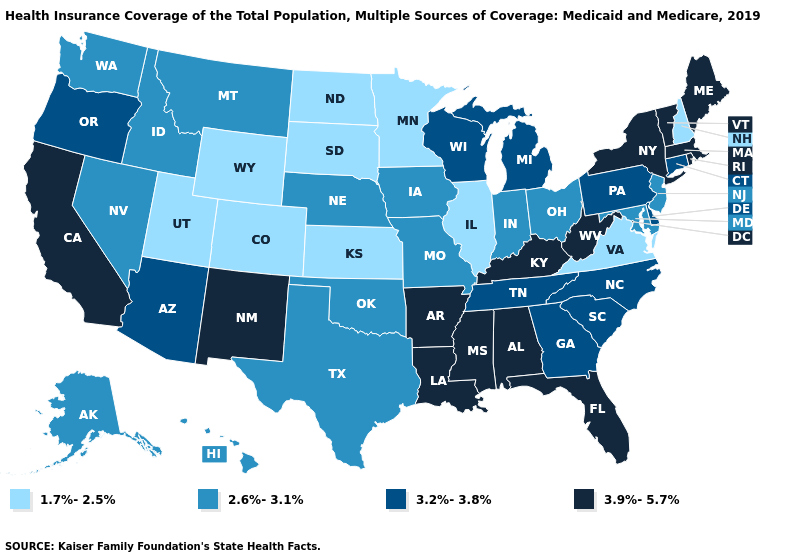What is the value of Oregon?
Be succinct. 3.2%-3.8%. What is the lowest value in states that border Kentucky?
Quick response, please. 1.7%-2.5%. Does New Hampshire have the highest value in the Northeast?
Write a very short answer. No. What is the lowest value in the Northeast?
Be succinct. 1.7%-2.5%. Name the states that have a value in the range 3.2%-3.8%?
Be succinct. Arizona, Connecticut, Delaware, Georgia, Michigan, North Carolina, Oregon, Pennsylvania, South Carolina, Tennessee, Wisconsin. Does Texas have the highest value in the South?
Give a very brief answer. No. What is the highest value in states that border South Carolina?
Concise answer only. 3.2%-3.8%. What is the highest value in the USA?
Be succinct. 3.9%-5.7%. Is the legend a continuous bar?
Be succinct. No. Among the states that border Texas , does New Mexico have the highest value?
Give a very brief answer. Yes. What is the value of North Dakota?
Be succinct. 1.7%-2.5%. What is the value of Nebraska?
Keep it brief. 2.6%-3.1%. What is the value of Iowa?
Be succinct. 2.6%-3.1%. Does Michigan have the highest value in the USA?
Concise answer only. No. 